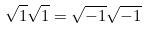Convert formula to latex. <formula><loc_0><loc_0><loc_500><loc_500>\sqrt { 1 } \sqrt { 1 } = \sqrt { - 1 } \sqrt { - 1 }</formula> 